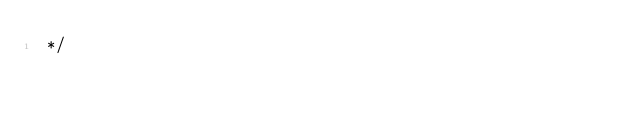<code> <loc_0><loc_0><loc_500><loc_500><_CSS_> */
</code> 